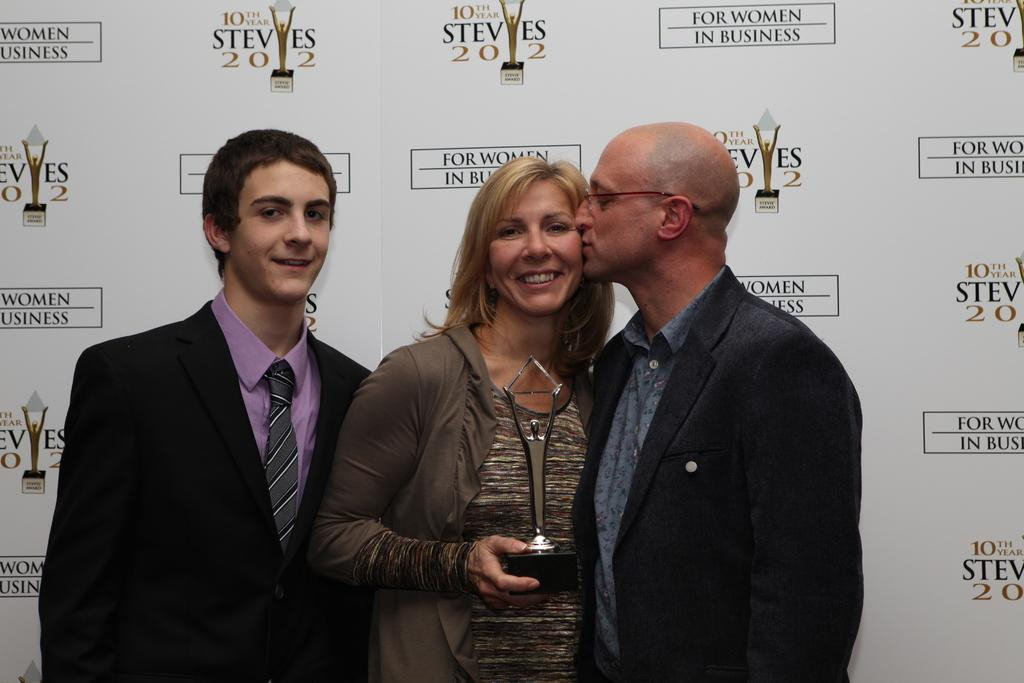How many people are in the image? There are three persons in the image. What is one person holding in the image? One person is holding an award. What can be seen in the background of the image? There is a board in the background of the image. How many crates are visible in the image? There are no crates present in the image. What type of wall is visible in the image? There is no wall visible in the image. 